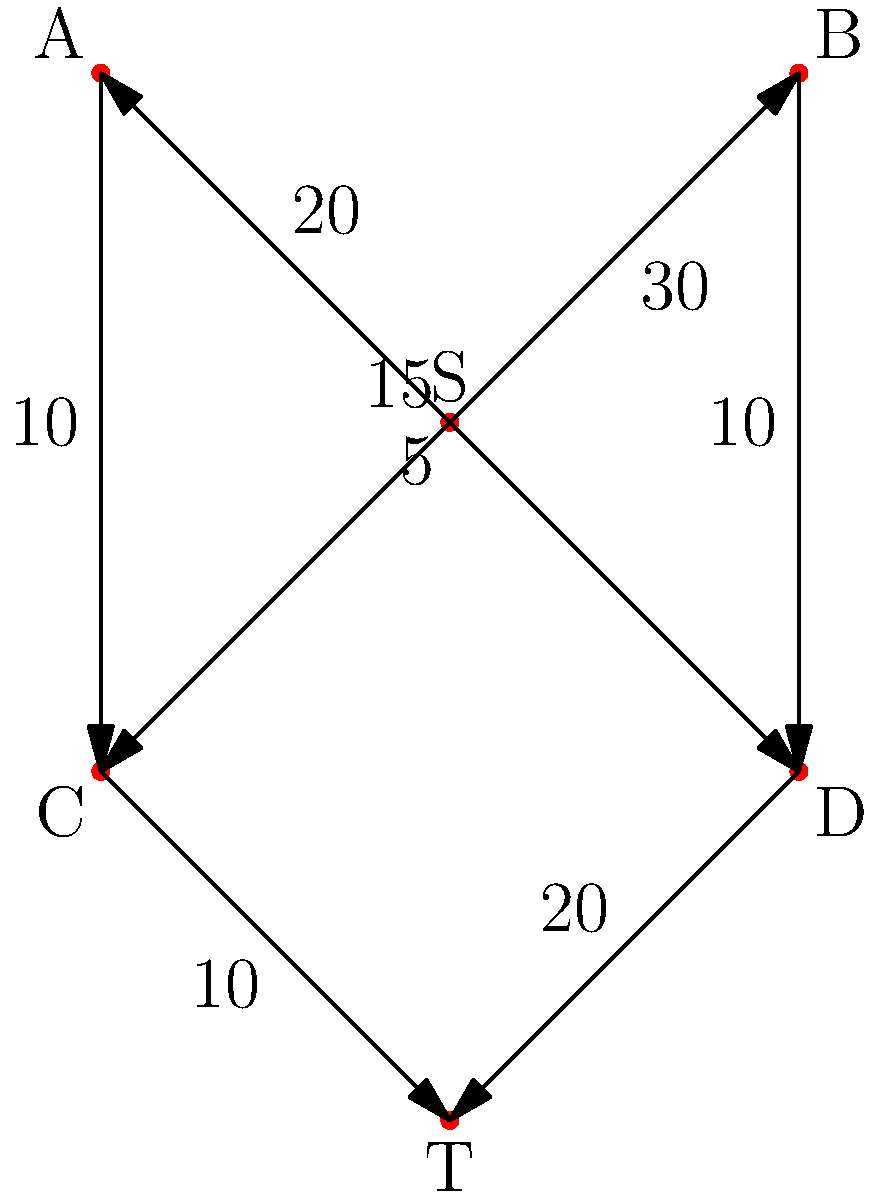During a sell-out Cutters match, the stadium management wants to maximize the flow of spectators through different entrances. The diagram shows the network of paths and their capacities (in hundreds of people per hour) between the source (S), intermediate points (A, B, C, D), and the target (T). What is the maximum number of spectators that can enter the stadium per hour? To solve this maximum flow problem, we can use the Ford-Fulkerson algorithm:

1. Initialize all flows to 0.
2. Find an augmenting path from S to T:
   a) S → A → C → T (min capacity: 10)
   b) S → B → D → T (min capacity: 20)
   c) S → A → D → T (min capacity: 5)
   d) S → B → C → T (min capacity: 10)

3. After these paths, we have:
   - Flow S → A: 15
   - Flow S → B: 30
   - Flow A → C: 10
   - Flow A → D: 5
   - Flow B → C: 10
   - Flow B → D: 20
   - Flow C → T: 20
   - Flow D → T: 25

4. No more augmenting paths exist, so the algorithm terminates.

5. The maximum flow is the sum of flows into T: 20 + 25 = 45.

Therefore, the maximum number of spectators that can enter the stadium per hour is 45 * 100 = 4500.
Answer: 4500 spectators per hour 